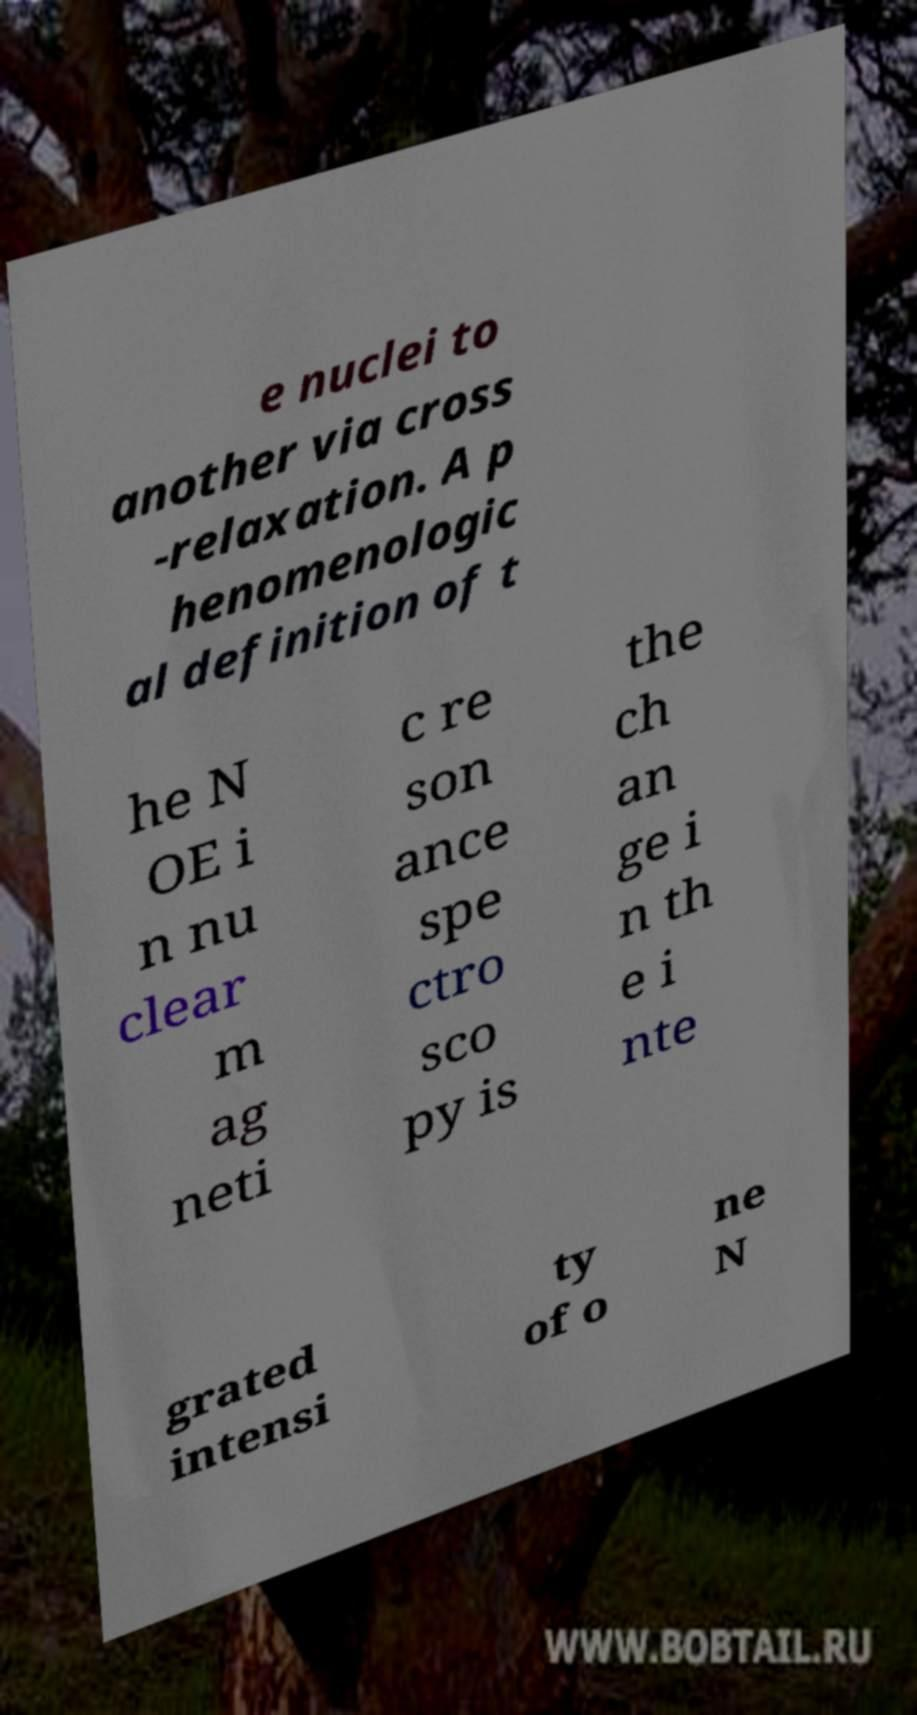Could you extract and type out the text from this image? e nuclei to another via cross -relaxation. A p henomenologic al definition of t he N OE i n nu clear m ag neti c re son ance spe ctro sco py is the ch an ge i n th e i nte grated intensi ty of o ne N 